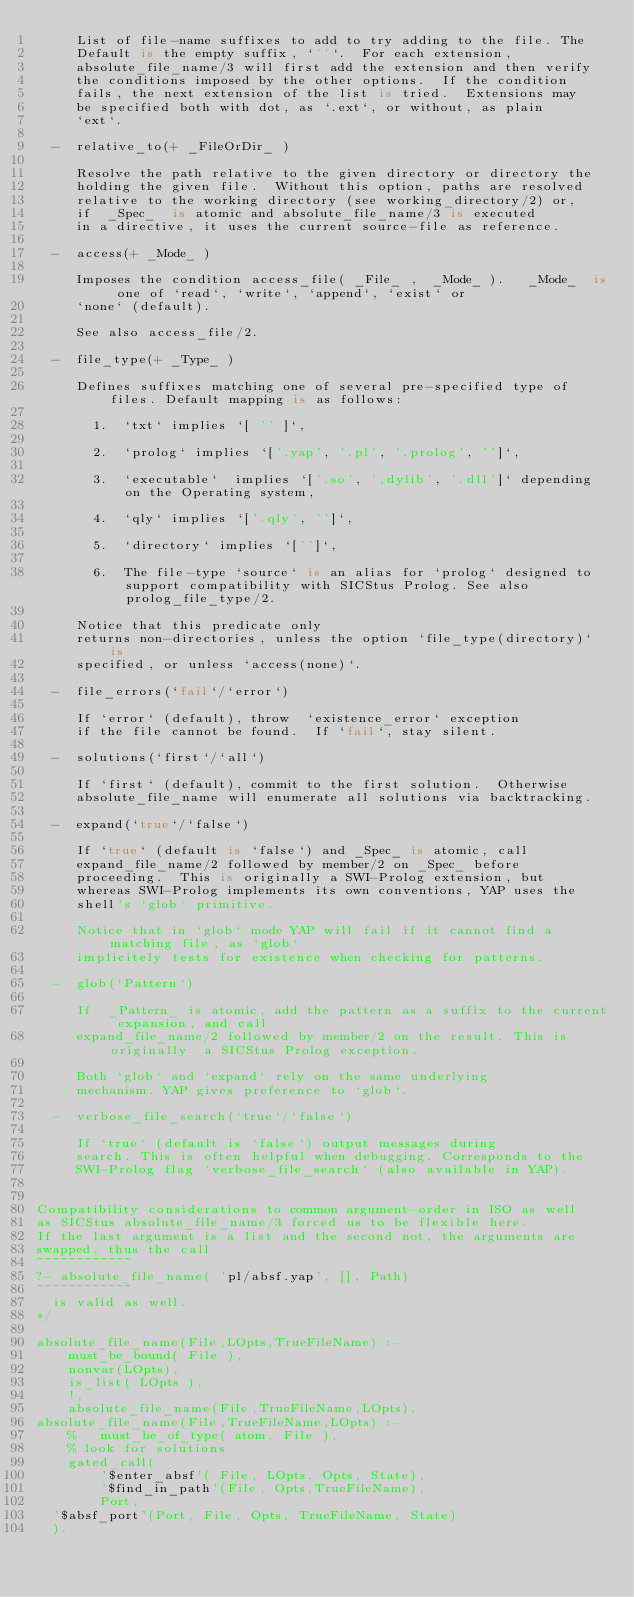<code> <loc_0><loc_0><loc_500><loc_500><_Prolog_>     List of file-name suffixes to add to try adding to the file. The
     Default is the empty suffix, `''`.  For each extension,
     absolute_file_name/3 will first add the extension and then verify
     the conditions imposed by the other options.  If the condition
     fails, the next extension of the list is tried.  Extensions may
     be specified both with dot, as `.ext`, or without, as plain
     `ext`.

  -  relative_to(+ _FileOrDir_ )

     Resolve the path relative to the given directory or directory the
     holding the given file.  Without this option, paths are resolved
     relative to the working directory (see working_directory/2) or,
     if  _Spec_  is atomic and absolute_file_name/3 is executed
     in a directive, it uses the current source-file as reference.

  -  access(+ _Mode_ )

     Imposes the condition access_file( _File_ ,  _Mode_ ).   _Mode_  is one of `read`, `write`, `append`, `exist` or
     `none` (default).

     See also access_file/2.

  -  file_type(+ _Type_ )

     Defines suffixes matching one of several pre-specified type of files. Default mapping is as follows:

       1.  `txt` implies `[ '' ]`,

       2.  `prolog` implies `['.yap', '.pl', '.prolog', '']`,

       3.  `executable`  implies `['.so', ',dylib', '.dll']` depending on the Operating system,

       4.  `qly` implies `['.qly', '']`,

       5.  `directory` implies `['']`,

       6.  The file-type `source` is an alias for `prolog` designed to support compatibility with SICStus Prolog. See also prolog_file_type/2.

     Notice that this predicate only
     returns non-directories, unless the option `file_type(directory)` is
     specified, or unless `access(none)`.

  -  file_errors(`fail`/`error`)

     If `error` (default), throw  `existence_error` exception
     if the file cannot be found.  If `fail`, stay silent.

  -  solutions(`first`/`all`)

     If `first` (default), commit to the first solution.  Otherwise
     absolute_file_name will enumerate all solutions via backtracking.

  -  expand(`true`/`false`)

     If `true` (default is `false`) and _Spec_ is atomic, call
     expand_file_name/2 followed by member/2 on _Spec_ before
     proceeding.  This is originally a SWI-Prolog extension, but
     whereas SWI-Prolog implements its own conventions, YAP uses the
     shell's `glob` primitive.

     Notice that in `glob` mode YAP will fail if it cannot find a matching file, as `glob`
     implicitely tests for existence when checking for patterns.

  -  glob(`Pattern`)

     If  _Pattern_ is atomic, add the pattern as a suffix to the current expansion, and call
     expand_file_name/2 followed by member/2 on the result. This is originally  a SICStus Prolog exception.

     Both `glob` and `expand` rely on the same underlying
     mechanism. YAP gives preference to `glob`.

  -  verbose_file_search(`true`/`false`)

     If `true` (default is `false`) output messages during
     search. This is often helpful when debugging. Corresponds to the
     SWI-Prolog flag `verbose_file_search` (also available in YAP).


Compatibility considerations to common argument-order in ISO as well
as SICStus absolute_file_name/3 forced us to be flexible here.
If the last argument is a list and the second not, the arguments are
swapped, thus the call
~~~~~~~~~~~~
?- absolute_file_name( 'pl/absf.yap', [], Path)
~~~~~~~~~~~~
  is valid as well.
*/

absolute_file_name(File,LOpts,TrueFileName) :-
    must_be_bound( File ),
    nonvar(LOpts),
    is_list( LOpts ),
    !,
    absolute_file_name(File,TrueFileName,LOpts).
absolute_file_name(File,TrueFileName,LOpts) :-
    %   must_be_of_type( atom, File ),
    % look for solutions    
    gated_call(
        '$enter_absf'( File, LOpts, Opts, State),
        '$find_in_path'(File, Opts,TrueFileName),
        Port,
	'$absf_port'(Port, File, Opts, TrueFileName, State)
	).

</code> 